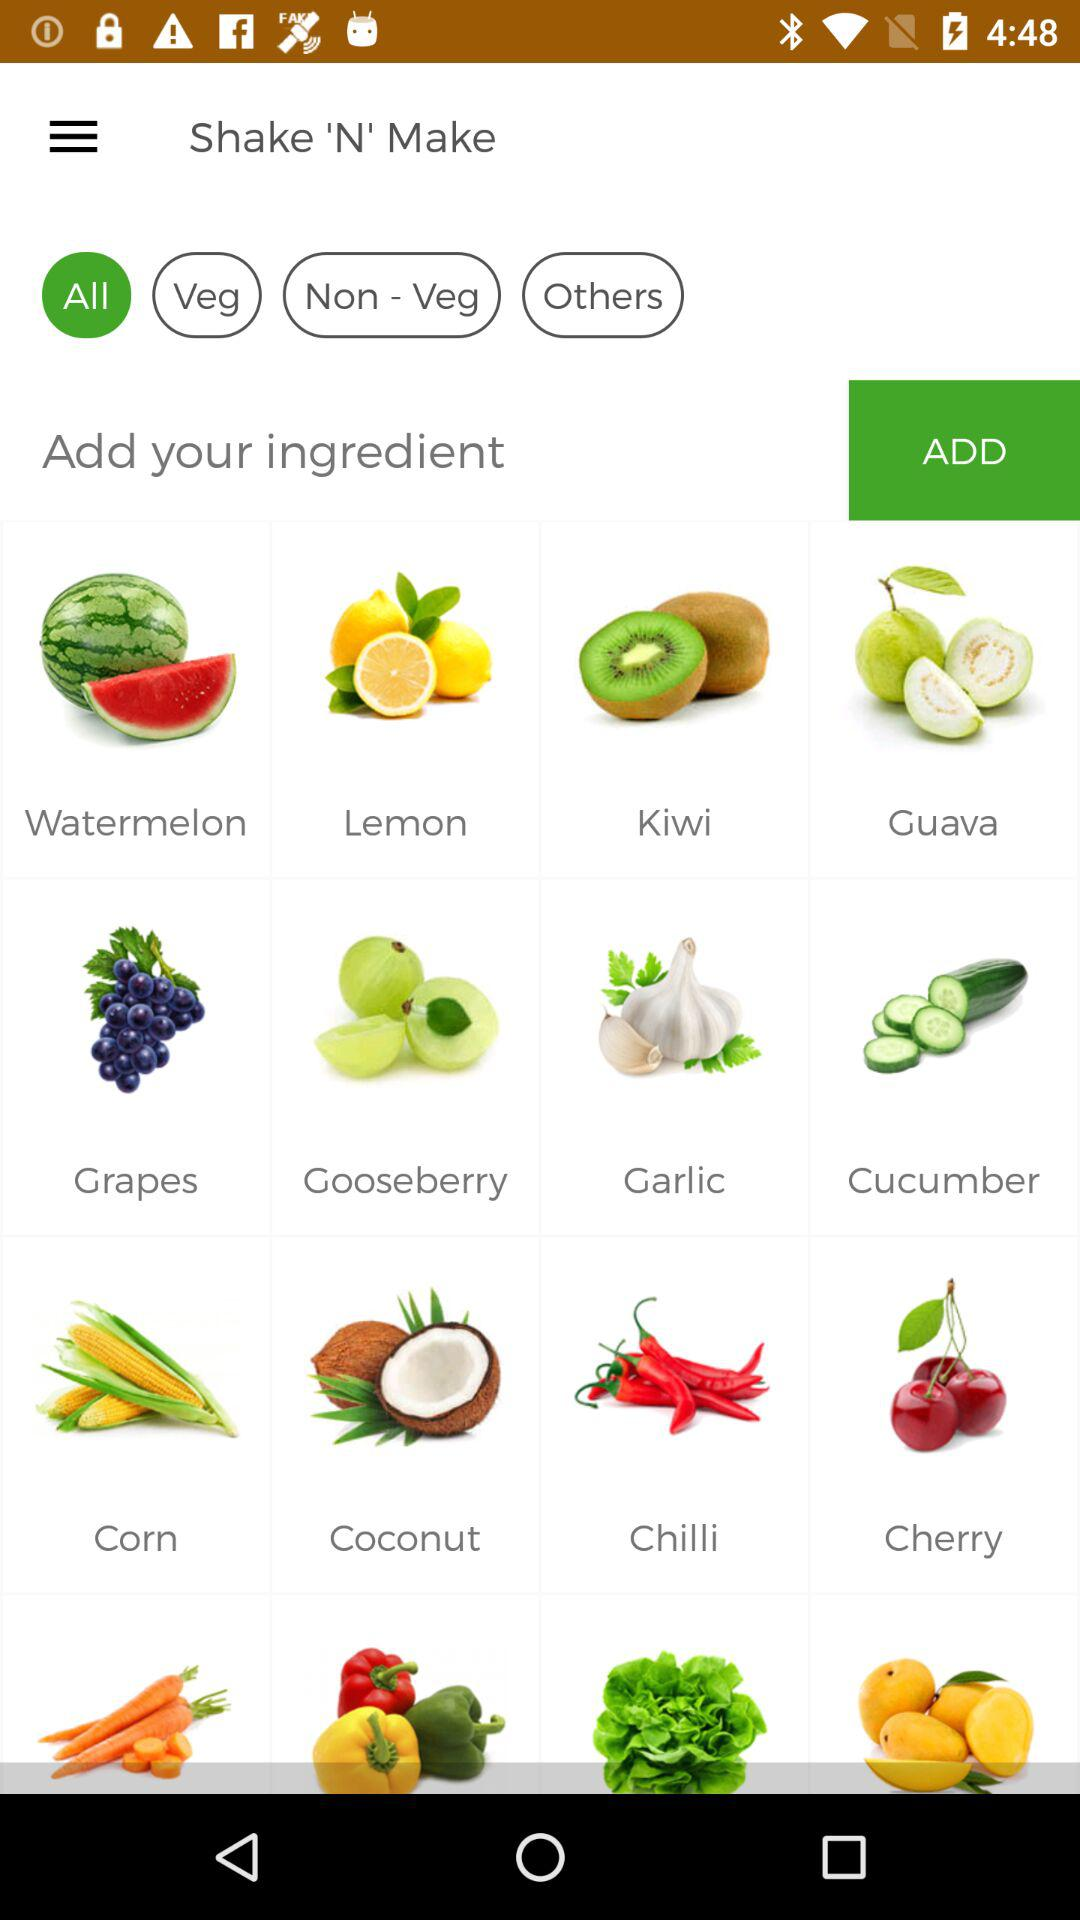Which option is selected? The selected option is "All". 